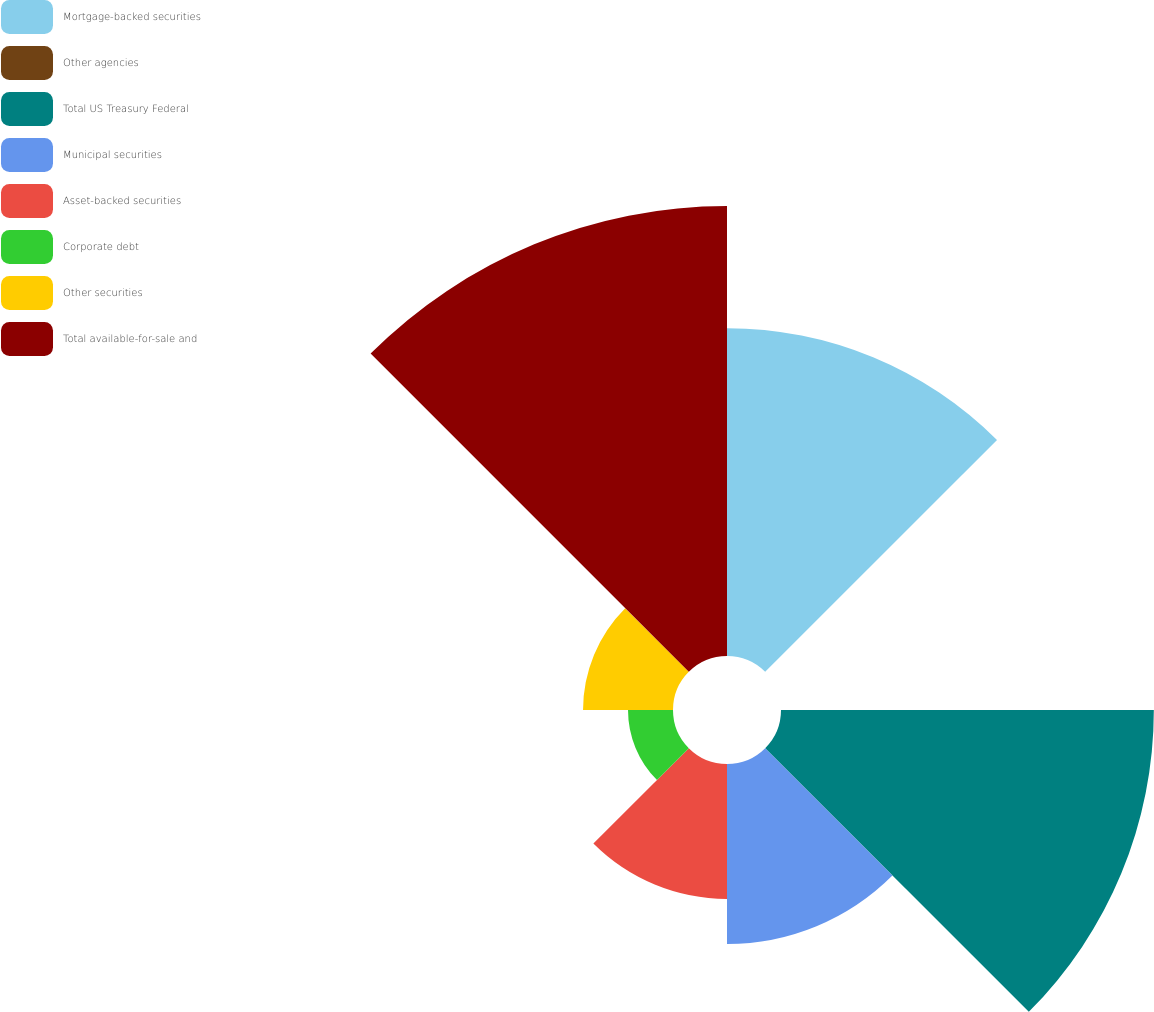Convert chart. <chart><loc_0><loc_0><loc_500><loc_500><pie_chart><fcel>Mortgage-backed securities<fcel>Other agencies<fcel>Total US Treasury Federal<fcel>Municipal securities<fcel>Asset-backed securities<fcel>Corporate debt<fcel>Other securities<fcel>Total available-for-sale and<nl><fcel>20.48%<fcel>0.0%<fcel>23.29%<fcel>11.24%<fcel>8.43%<fcel>2.81%<fcel>5.62%<fcel>28.11%<nl></chart> 